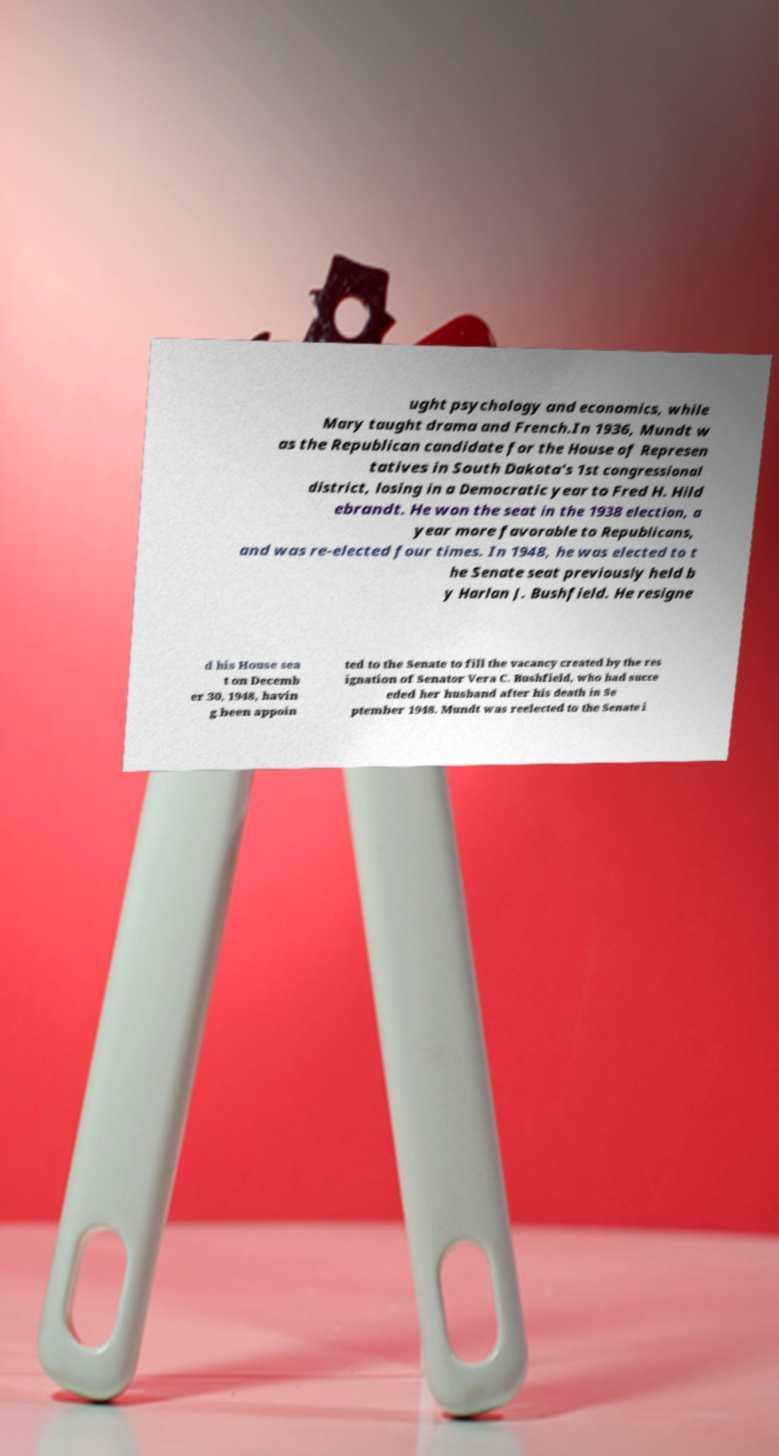Can you read and provide the text displayed in the image?This photo seems to have some interesting text. Can you extract and type it out for me? ught psychology and economics, while Mary taught drama and French.In 1936, Mundt w as the Republican candidate for the House of Represen tatives in South Dakota's 1st congressional district, losing in a Democratic year to Fred H. Hild ebrandt. He won the seat in the 1938 election, a year more favorable to Republicans, and was re-elected four times. In 1948, he was elected to t he Senate seat previously held b y Harlan J. Bushfield. He resigne d his House sea t on Decemb er 30, 1948, havin g been appoin ted to the Senate to fill the vacancy created by the res ignation of Senator Vera C. Bushfield, who had succe eded her husband after his death in Se ptember 1948. Mundt was reelected to the Senate i 